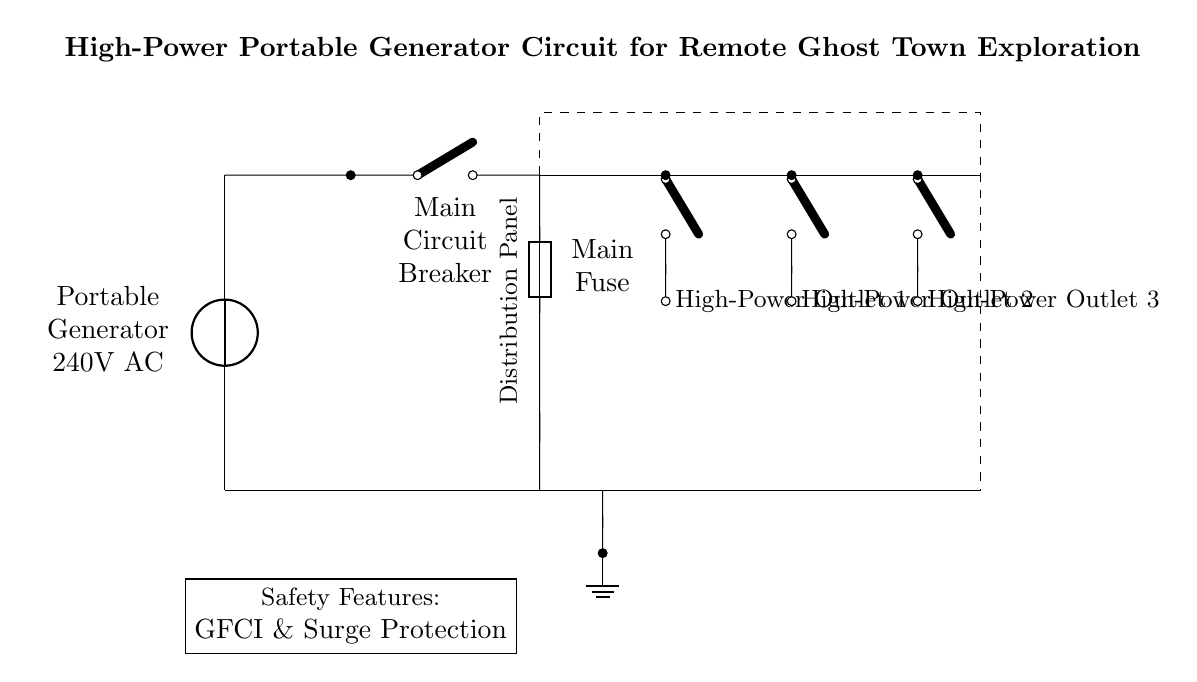What type of generator is used in this circuit? The generator is labeled as a portable generator, specifically indicating it provides 240V AC power.
Answer: Portable generator 240V AC How many high-power outlets are available? The diagram shows three separate high-power outlets, each connected through switches.
Answer: Three What safety features are indicated in the circuit? The diagram lists the main fuse and includes a note for GFCI and surge protection, which are critical safety components.
Answer: GFCI & Surge Protection What function does the circuit breaker serve? The circuit breaker acts as a protective device that can interrupt the current flow to prevent damage to the system in case of overload or short circuit conditions.
Answer: Protective device How is the ground connected in the circuit? The ground is connected to the ground symbol at the bottom of the circuit, providing a pathway for fault current and enhancing safety.
Answer: Ground symbol Why is a fuse included in this circuit? The fuse is included to provide overcurrent protection by breaking the circuit if the current exceeds a safe level, thereby preventing damage to the generator or connected devices.
Answer: Overcurrent protection What is the purpose of the distribution panel? The distribution panel serves to house and manage multiple circuit connections and distribute power to the high-power outlets efficiently.
Answer: Manage multiple connections 